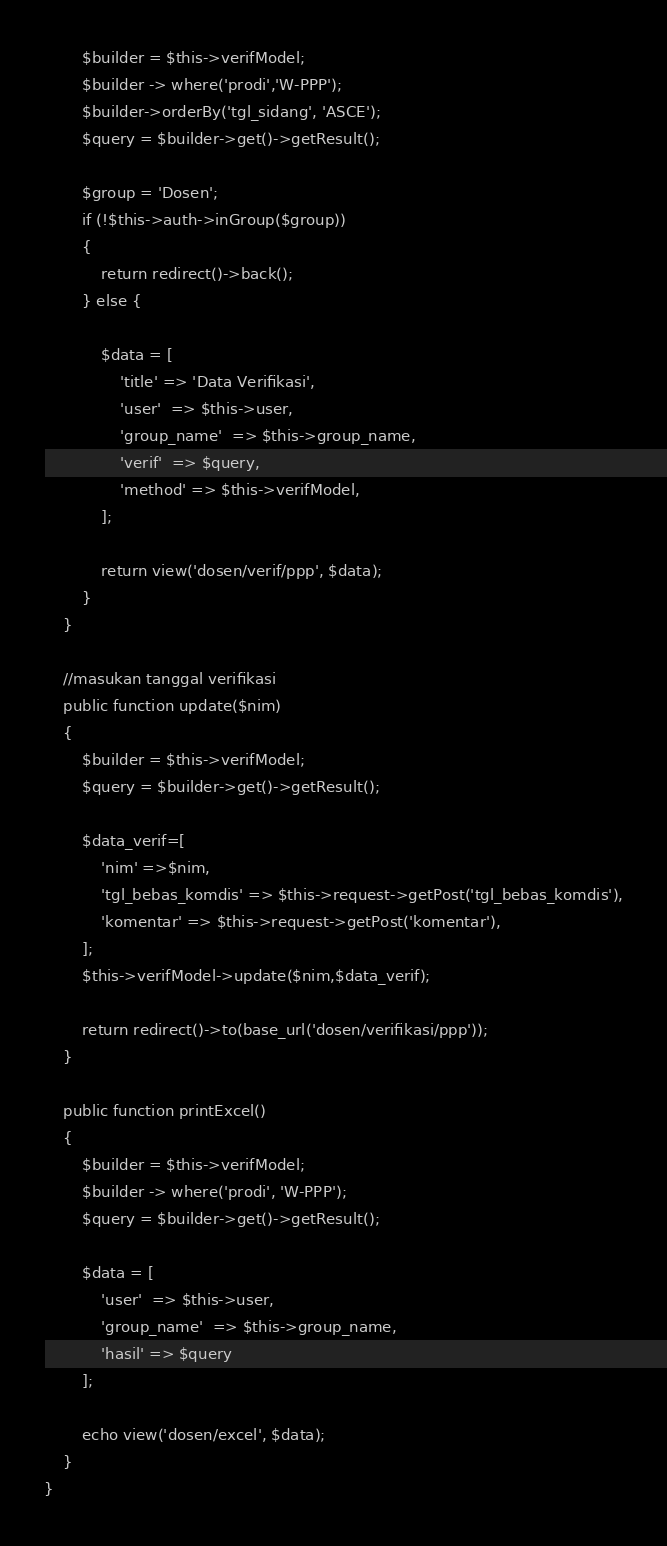Convert code to text. <code><loc_0><loc_0><loc_500><loc_500><_PHP_>        $builder = $this->verifModel;
        $builder -> where('prodi','W-PPP');
        $builder->orderBy('tgl_sidang', 'ASCE');
        $query = $builder->get()->getResult();

        $group = 'Dosen';
        if (!$this->auth->inGroup($group))
        {
            return redirect()->back();
        } else {

            $data = [
                'title' => 'Data Verifikasi',
                'user'  => $this->user,
                'group_name'  => $this->group_name,
                'verif'  => $query,
                'method' => $this->verifModel,
            ];
    
            return view('dosen/verif/ppp', $data);
        }
    }

    //masukan tanggal verifikasi
    public function update($nim)
    {
        $builder = $this->verifModel;
        $query = $builder->get()->getResult();

        $data_verif=[
            'nim' =>$nim,
            'tgl_bebas_komdis' => $this->request->getPost('tgl_bebas_komdis'),
            'komentar' => $this->request->getPost('komentar'),
        ];
        $this->verifModel->update($nim,$data_verif);

        return redirect()->to(base_url('dosen/verifikasi/ppp'));
    }

    public function printExcel()
    {
        $builder = $this->verifModel;
        $builder -> where('prodi', 'W-PPP');
        $query = $builder->get()->getResult();

        $data = [
            'user'  => $this->user,
            'group_name'  => $this->group_name,
            'hasil' => $query
        ];

        echo view('dosen/excel', $data);
    }
}</code> 